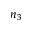<formula> <loc_0><loc_0><loc_500><loc_500>n _ { 3 }</formula> 